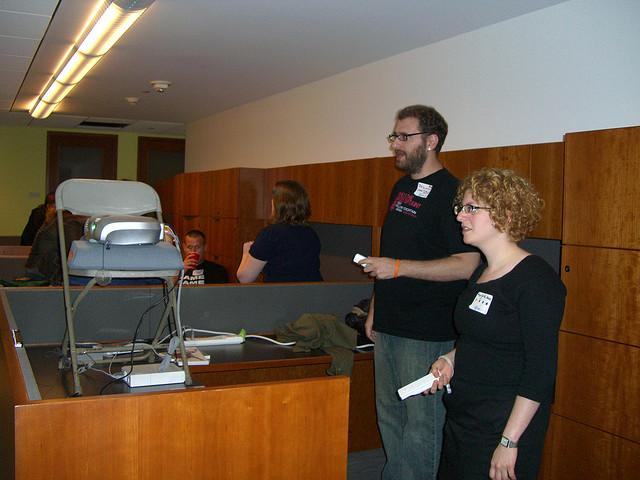What kind of label is on their shirts? Please explain your reasoning. name tag. The label is a name tag. 